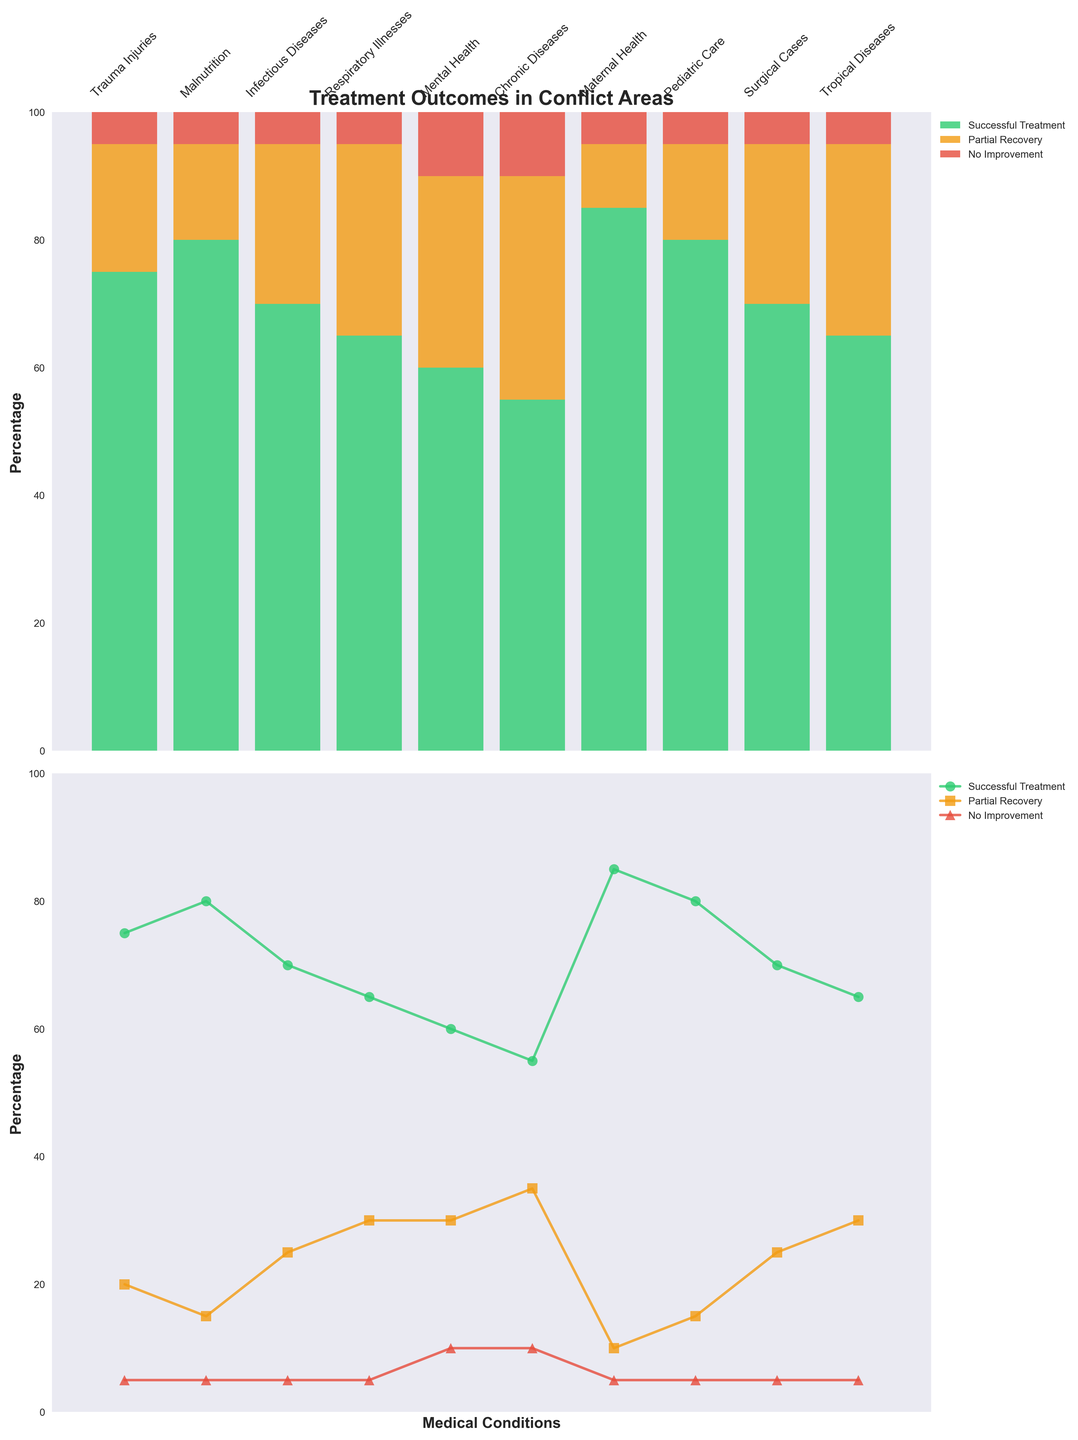Which medical condition has the highest successful treatment percentage? Look at the bar heights for successful treatment. Maternal Health has the highest bar with 85%.
Answer: Maternal Health What is the percentage of partial recovery for Chronic Diseases? Refer to the bar for Chronic Diseases, observe the segment representing partial recovery, it is labeled 35%.
Answer: 35% Which condition has the lowest successful treatment rate? Compare the heights of the successful treatment bars. Chronic Diseases has the lowest successful treatment rate at 55%.
Answer: Chronic Diseases How does the successful treatment rate of Mental Health conditions compare to Respiratory Illnesses? Check the successful treatment bars for both conditions. Mental Health is at 60%, and Respiratory Illnesses is at 65%. 60% vs 65%.
Answer: Mental Health is lower For which condition is partial recovery equal to no improvement? Look for bars where the heights of the partial recovery and no improvement segments are the same. Mental Health and Chronic Diseases both have 30% for partial recovery and 10% for no improvement, the sum is 40% for both.
Answer: Mental Health and Chronic Diseases What is the total percentage of patients who either partially recover or see no improvement for Trauma Injuries? Add the partial recovery and no improvement percentages for Trauma Injuries: 20% + 5%.
Answer: 25% Which condition has the highest percentage of patients with no improvement? Compare the heights of the no improvement segments for each condition. Mental Health and Chronic Diseases both have the highest at 10%.
Answer: Mental Health and Chronic Diseases What is the difference in the successful treatment rate between Pediatric Care and Tropical Diseases? Subtract the successful treatment rate of Tropical Diseases (65%) from Pediatric Care (80%): 80% - 65%.
Answer: 15% Compare the successful treatment rate of Malnutrition with Tropical Diseases. Which is higher and by how much? Malnutrition has a successful treatment rate of 80% while Tropical Diseases have 65%. Subtract 65% from 80% to find the difference, 80% - 65%.
Answer: Malnutrition is higher by 15% Which medical conditions have exactly 5% of patients with no improvement? Identify conditions with no improvement segment equal to 5%. Trauma Injuries, Malnutrition, Infectious Diseases, Respiratory Illnesses, Maternal Health, Pediatric Care, and Surgical Cases all fit.
Answer: Trauma Injuries, Malnutrition, Infectious Diseases, Respiratory Illnesses, Maternal Health, Pediatric Care, Surgical Cases 